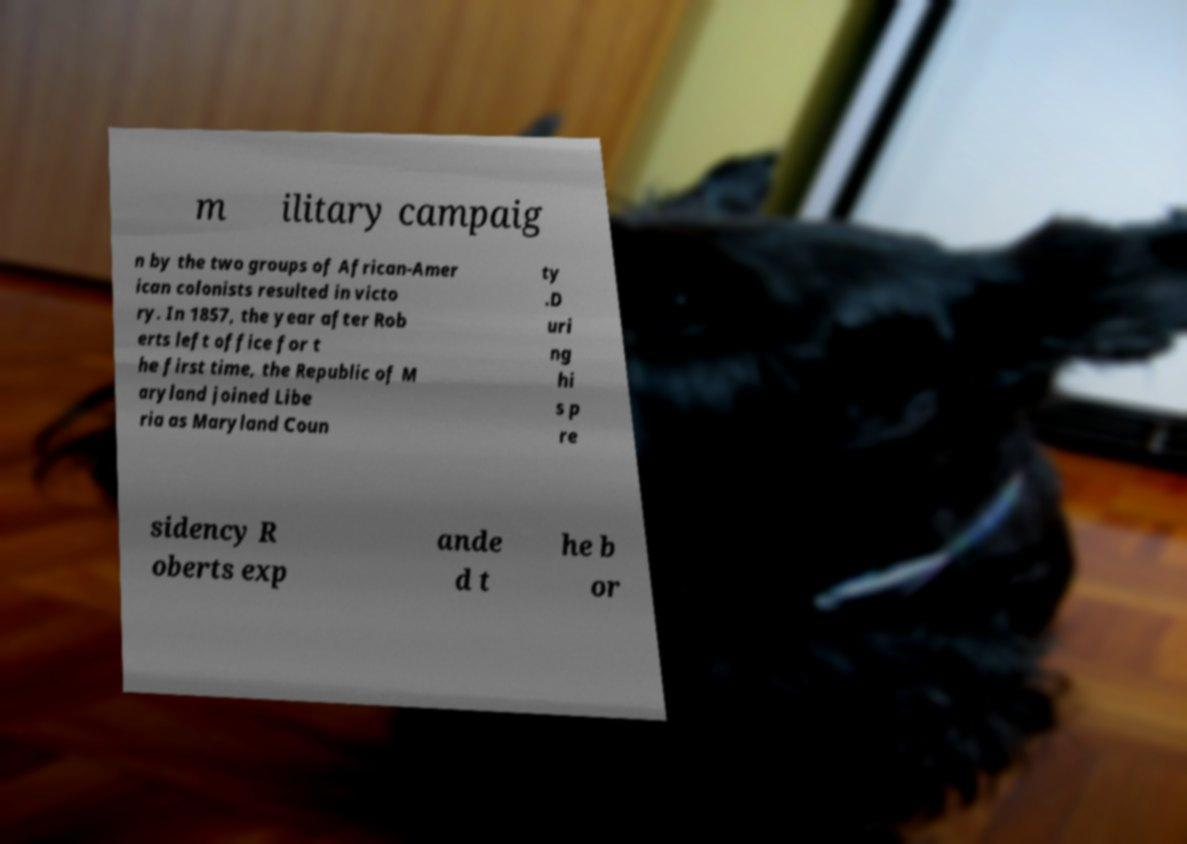Can you read and provide the text displayed in the image?This photo seems to have some interesting text. Can you extract and type it out for me? m ilitary campaig n by the two groups of African-Amer ican colonists resulted in victo ry. In 1857, the year after Rob erts left office for t he first time, the Republic of M aryland joined Libe ria as Maryland Coun ty .D uri ng hi s p re sidency R oberts exp ande d t he b or 